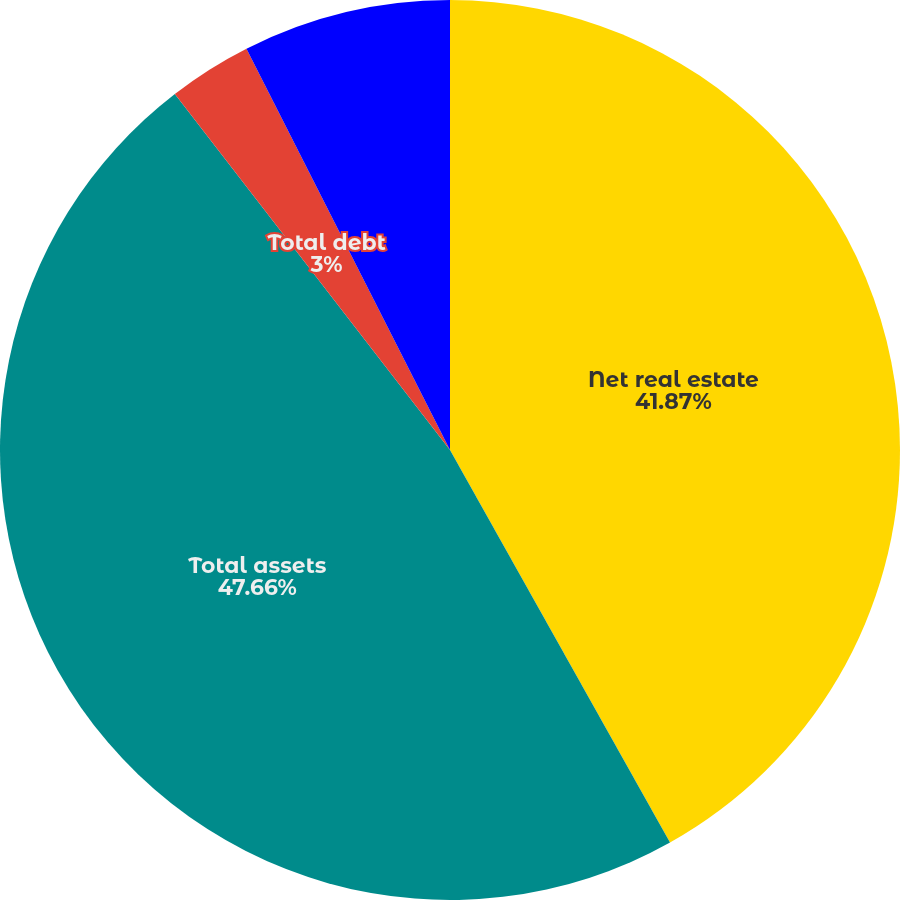<chart> <loc_0><loc_0><loc_500><loc_500><pie_chart><fcel>Net real estate<fcel>Total assets<fcel>Total debt<fcel>Total liabilities<nl><fcel>41.87%<fcel>47.66%<fcel>3.0%<fcel>7.47%<nl></chart> 